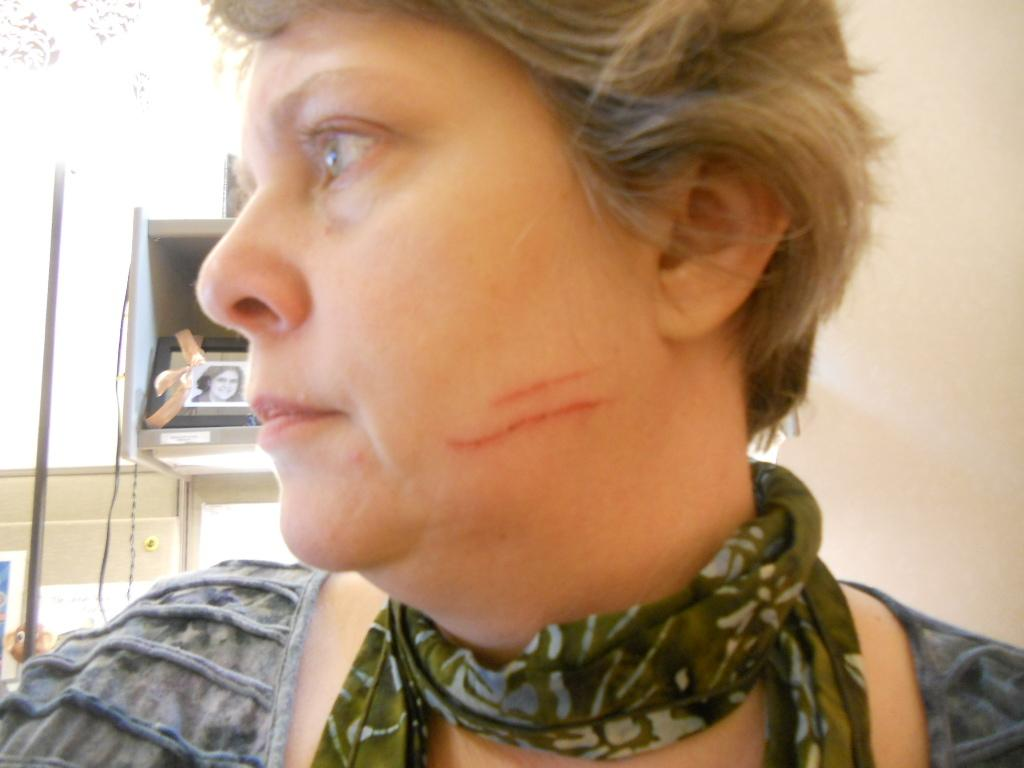What is present in the image? There is a person in the image. Can you describe the person's attire? The person is wearing a dress with different colors. What can be seen in the background of the image? There are objects visible in the background, including a frame. What is the color of the background? The background color is white. What type of yoke is being used by the person in the image? There is no yoke present in the image; it features a person wearing a dress with different colors and a white background. 